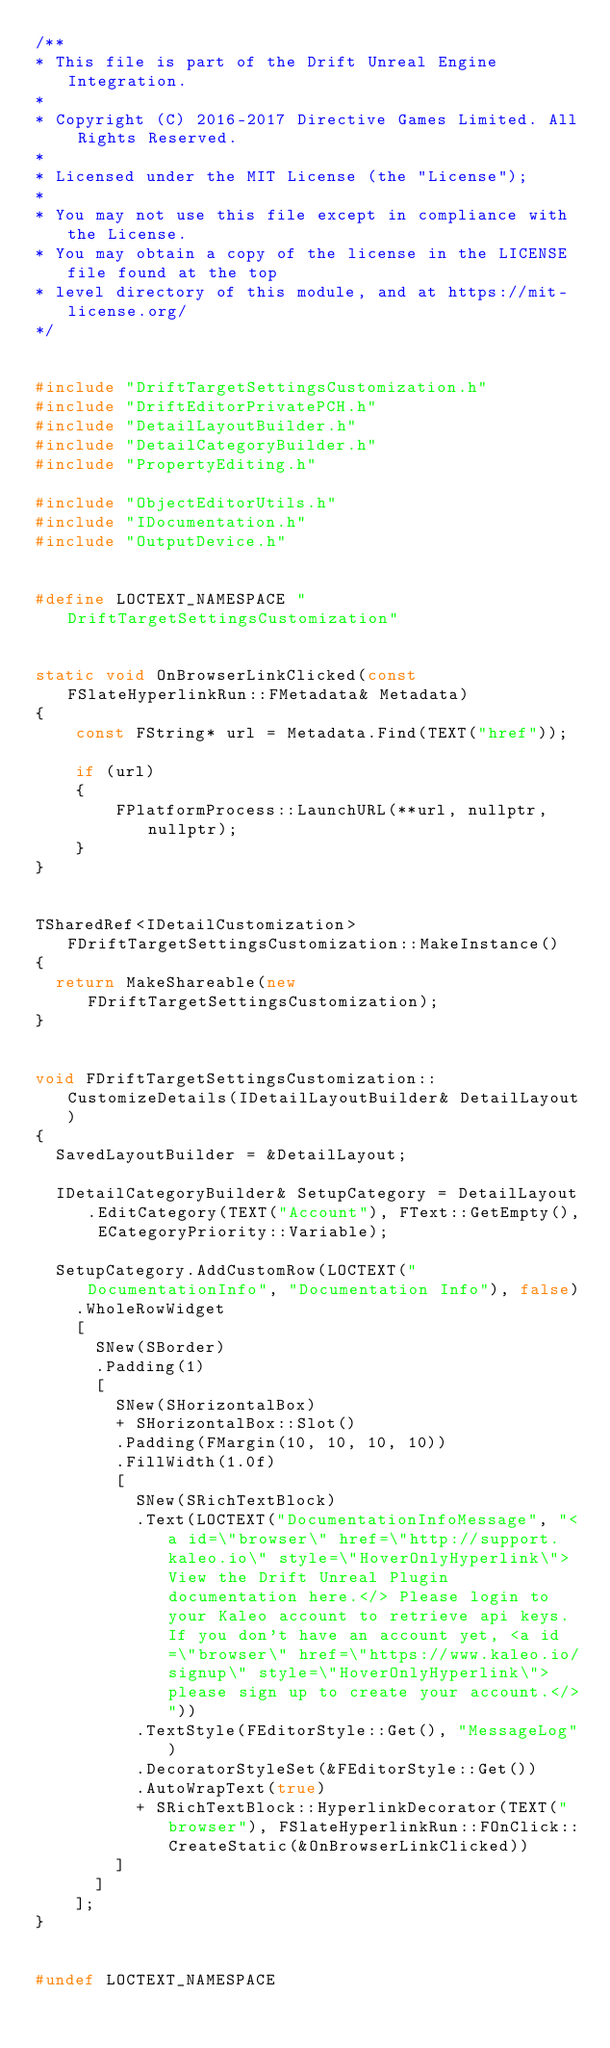<code> <loc_0><loc_0><loc_500><loc_500><_C++_>/**
* This file is part of the Drift Unreal Engine Integration.
*
* Copyright (C) 2016-2017 Directive Games Limited. All Rights Reserved.
*
* Licensed under the MIT License (the "License");
*
* You may not use this file except in compliance with the License.
* You may obtain a copy of the license in the LICENSE file found at the top
* level directory of this module, and at https://mit-license.org/
*/


#include "DriftTargetSettingsCustomization.h"
#include "DriftEditorPrivatePCH.h"
#include "DetailLayoutBuilder.h"
#include "DetailCategoryBuilder.h"
#include "PropertyEditing.h"

#include "ObjectEditorUtils.h"
#include "IDocumentation.h"
#include "OutputDevice.h"


#define LOCTEXT_NAMESPACE "DriftTargetSettingsCustomization"


static void OnBrowserLinkClicked(const FSlateHyperlinkRun::FMetadata& Metadata)
{
    const FString* url = Metadata.Find(TEXT("href"));
    
    if (url)
    {
        FPlatformProcess::LaunchURL(**url, nullptr, nullptr);
    }
}


TSharedRef<IDetailCustomization> FDriftTargetSettingsCustomization::MakeInstance()
{
	return MakeShareable(new FDriftTargetSettingsCustomization);
}


void FDriftTargetSettingsCustomization::CustomizeDetails(IDetailLayoutBuilder& DetailLayout)
{
	SavedLayoutBuilder = &DetailLayout;

	IDetailCategoryBuilder& SetupCategory = DetailLayout.EditCategory(TEXT("Account"), FText::GetEmpty(), ECategoryPriority::Variable);

	SetupCategory.AddCustomRow(LOCTEXT("DocumentationInfo", "Documentation Info"), false)
		.WholeRowWidget
		[
			SNew(SBorder)
			.Padding(1)
			[
				SNew(SHorizontalBox)
				+ SHorizontalBox::Slot()
				.Padding(FMargin(10, 10, 10, 10))
				.FillWidth(1.0f)
				[
					SNew(SRichTextBlock)
					.Text(LOCTEXT("DocumentationInfoMessage", "<a id=\"browser\" href=\"http://support.kaleo.io\" style=\"HoverOnlyHyperlink\">View the Drift Unreal Plugin documentation here.</> Please login to your Kaleo account to retrieve api keys. If you don't have an account yet, <a id=\"browser\" href=\"https://www.kaleo.io/signup\" style=\"HoverOnlyHyperlink\">please sign up to create your account.</>"))
					.TextStyle(FEditorStyle::Get(), "MessageLog")
					.DecoratorStyleSet(&FEditorStyle::Get())
					.AutoWrapText(true)
					+ SRichTextBlock::HyperlinkDecorator(TEXT("browser"), FSlateHyperlinkRun::FOnClick::CreateStatic(&OnBrowserLinkClicked))
				]
			]
		];
}


#undef LOCTEXT_NAMESPACE
</code> 